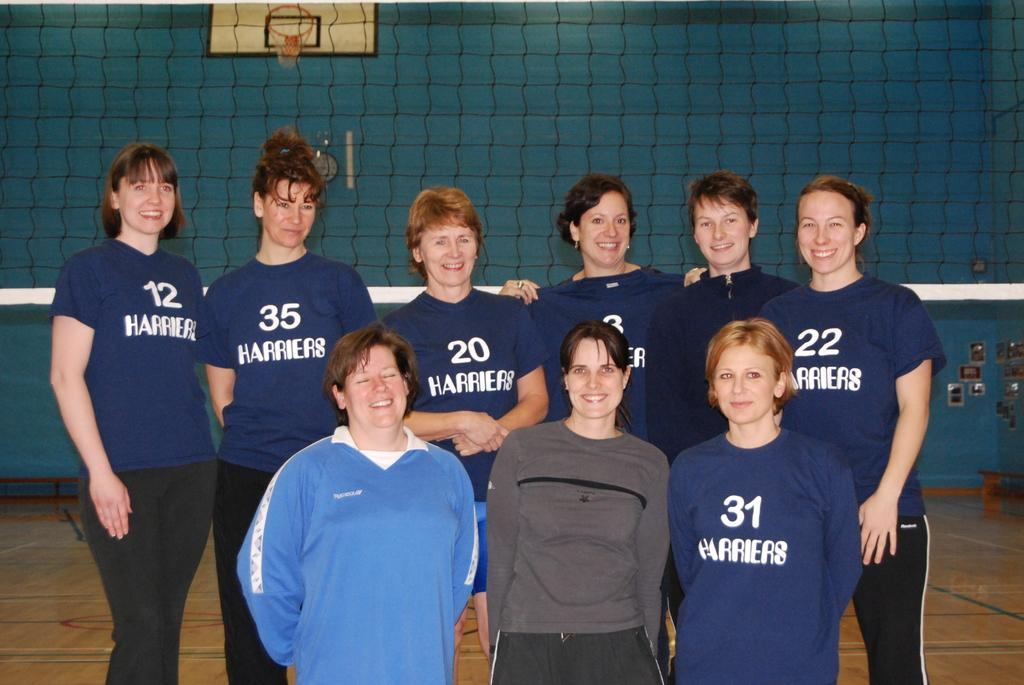<image>
Render a clear and concise summary of the photo. a few people with one wearing the number 12 